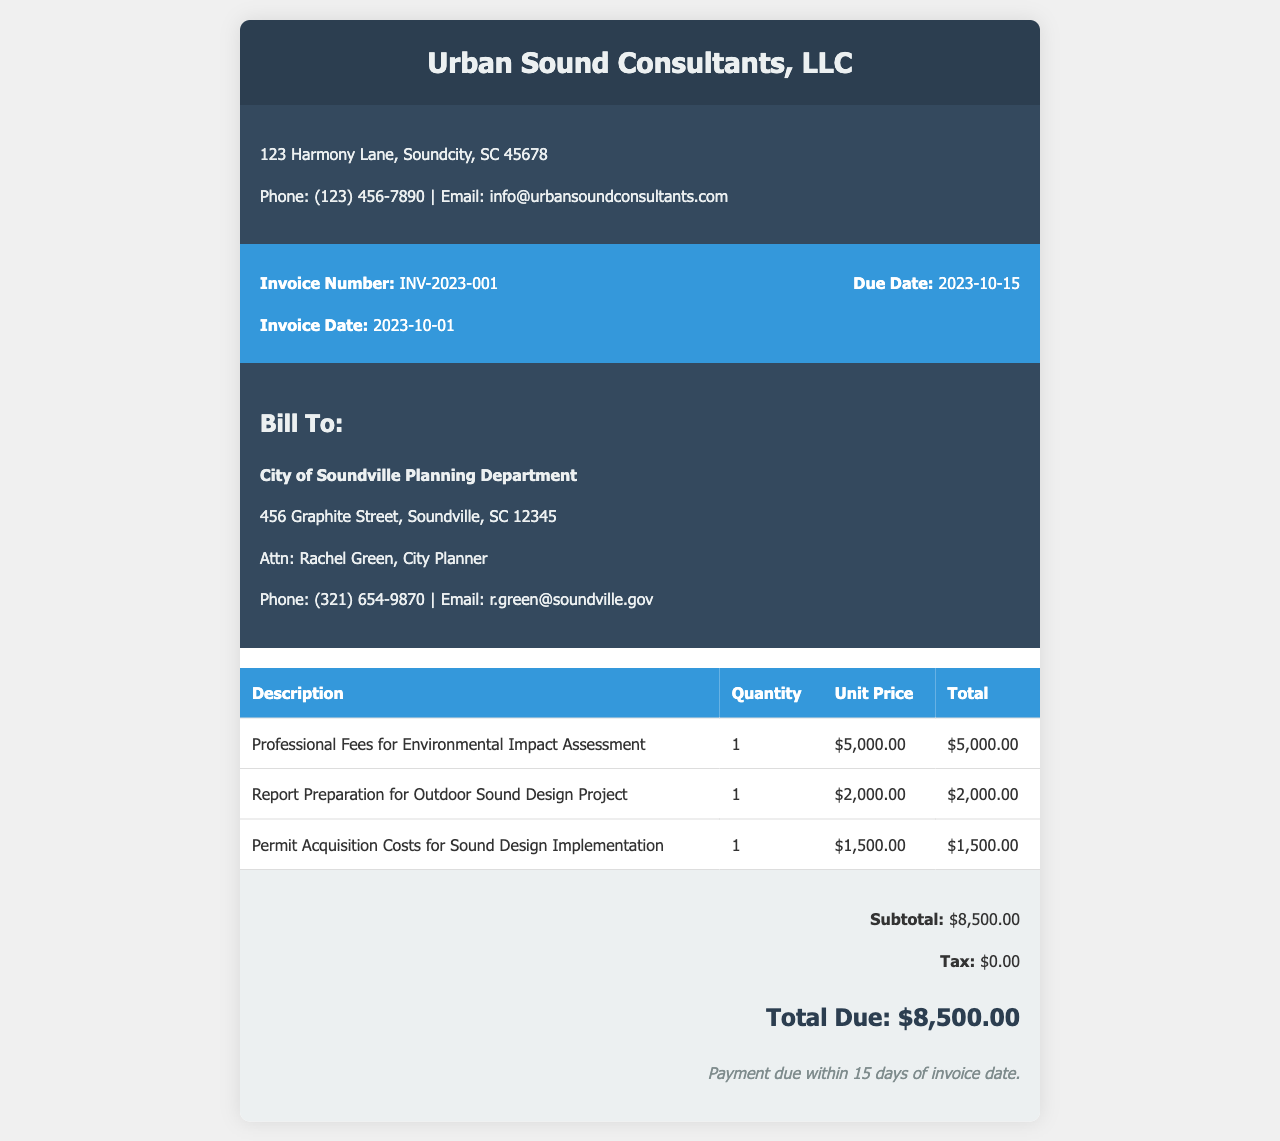What is the invoice number? The invoice number is clearly stated in the document for identification purposes.
Answer: INV-2023-001 Who is the billing recipient? The billing recipient is specified in the document to clarify who is being charged.
Answer: City of Soundville Planning Department What is the total amount due? The total amount due is provided in the summary section of the invoice document.
Answer: $8,500.00 When is the payment due date? The due date for payment is mentioned in the invoice details section.
Answer: 2023-10-15 How much were the professional fees? The amount for professional fees is listed in the breakdown of charges on the invoice.
Answer: $5,000.00 What is included in the report preparation charge? The charge item clearly states the specific service related to the outdoor sound design project.
Answer: Report Preparation for Outdoor Sound Design Project How many services were billed in total? The total number of services is determined from the itemized list in the invoice.
Answer: 3 What is the subtotal amount before tax? The subtotal amount before tax is shown in the summary of the invoice.
Answer: $8,500.00 What are the payment terms stated in the invoice? The payment terms outline the conditions for payment based on the invoice date.
Answer: Payment due within 15 days of invoice date 